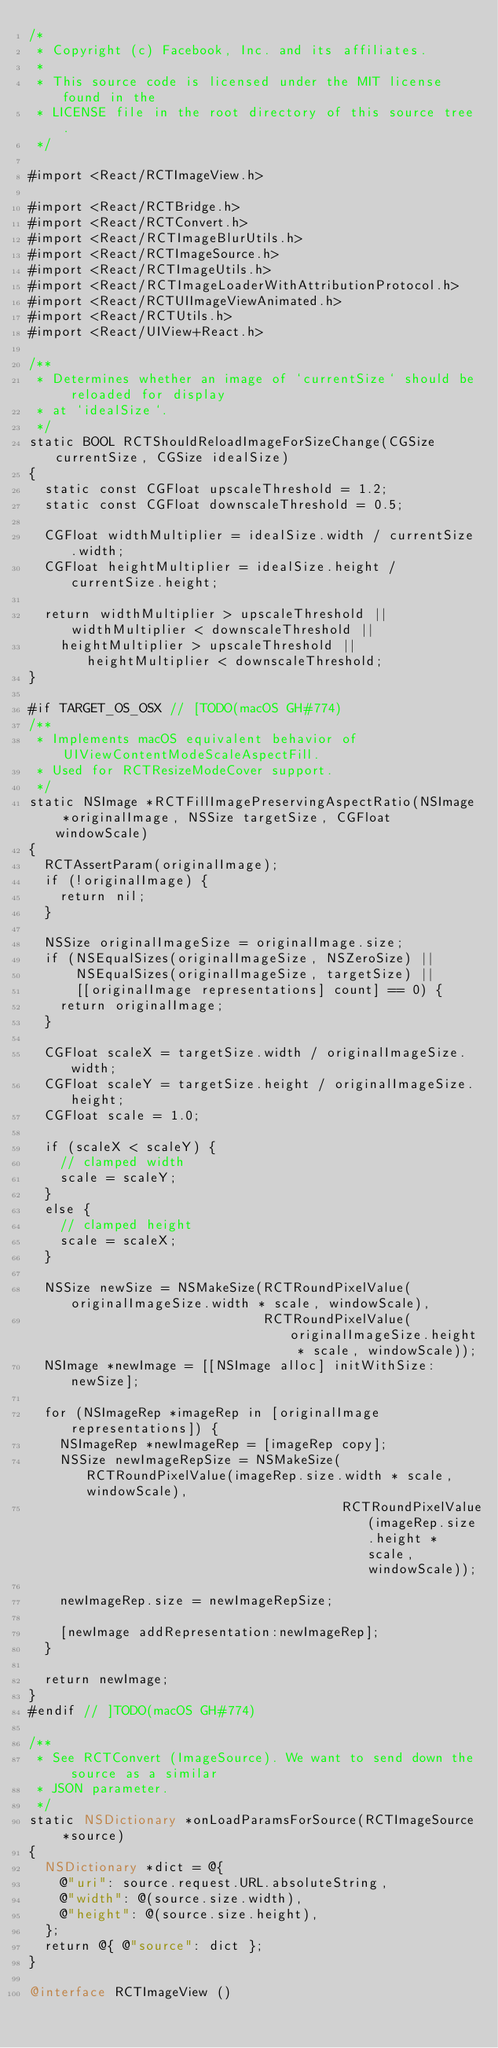Convert code to text. <code><loc_0><loc_0><loc_500><loc_500><_ObjectiveC_>/*
 * Copyright (c) Facebook, Inc. and its affiliates.
 *
 * This source code is licensed under the MIT license found in the
 * LICENSE file in the root directory of this source tree.
 */

#import <React/RCTImageView.h>

#import <React/RCTBridge.h>
#import <React/RCTConvert.h>
#import <React/RCTImageBlurUtils.h>
#import <React/RCTImageSource.h>
#import <React/RCTImageUtils.h>
#import <React/RCTImageLoaderWithAttributionProtocol.h>
#import <React/RCTUIImageViewAnimated.h>
#import <React/RCTUtils.h>
#import <React/UIView+React.h>

/**
 * Determines whether an image of `currentSize` should be reloaded for display
 * at `idealSize`.
 */
static BOOL RCTShouldReloadImageForSizeChange(CGSize currentSize, CGSize idealSize)
{
  static const CGFloat upscaleThreshold = 1.2;
  static const CGFloat downscaleThreshold = 0.5;

  CGFloat widthMultiplier = idealSize.width / currentSize.width;
  CGFloat heightMultiplier = idealSize.height / currentSize.height;

  return widthMultiplier > upscaleThreshold || widthMultiplier < downscaleThreshold ||
    heightMultiplier > upscaleThreshold || heightMultiplier < downscaleThreshold;
}

#if TARGET_OS_OSX // [TODO(macOS GH#774)
/**
 * Implements macOS equivalent behavior of UIViewContentModeScaleAspectFill.
 * Used for RCTResizeModeCover support.
 */
static NSImage *RCTFillImagePreservingAspectRatio(NSImage *originalImage, NSSize targetSize, CGFloat windowScale)
{
  RCTAssertParam(originalImage);
  if (!originalImage) {
    return nil;
  }

  NSSize originalImageSize = originalImage.size;
  if (NSEqualSizes(originalImageSize, NSZeroSize) ||
      NSEqualSizes(originalImageSize, targetSize) ||
      [[originalImage representations] count] == 0) {
    return originalImage;
  }

  CGFloat scaleX = targetSize.width / originalImageSize.width;
  CGFloat scaleY = targetSize.height / originalImageSize.height;
  CGFloat scale = 1.0;

  if (scaleX < scaleY) {
    // clamped width
    scale = scaleY;
  }
  else {
    // clamped height
    scale = scaleX;
  }

  NSSize newSize = NSMakeSize(RCTRoundPixelValue(originalImageSize.width * scale, windowScale),
                              RCTRoundPixelValue(originalImageSize.height * scale, windowScale));
  NSImage *newImage = [[NSImage alloc] initWithSize:newSize];

  for (NSImageRep *imageRep in [originalImage representations]) {
    NSImageRep *newImageRep = [imageRep copy];
    NSSize newImageRepSize = NSMakeSize(RCTRoundPixelValue(imageRep.size.width * scale, windowScale),
                                        RCTRoundPixelValue(imageRep.size.height * scale, windowScale));

    newImageRep.size = newImageRepSize;

    [newImage addRepresentation:newImageRep];
  }

  return newImage;
}
#endif // ]TODO(macOS GH#774)

/**
 * See RCTConvert (ImageSource). We want to send down the source as a similar
 * JSON parameter.
 */
static NSDictionary *onLoadParamsForSource(RCTImageSource *source)
{
  NSDictionary *dict = @{
    @"uri": source.request.URL.absoluteString,
    @"width": @(source.size.width),
    @"height": @(source.size.height),
  };
  return @{ @"source": dict };
}

@interface RCTImageView ()
</code> 